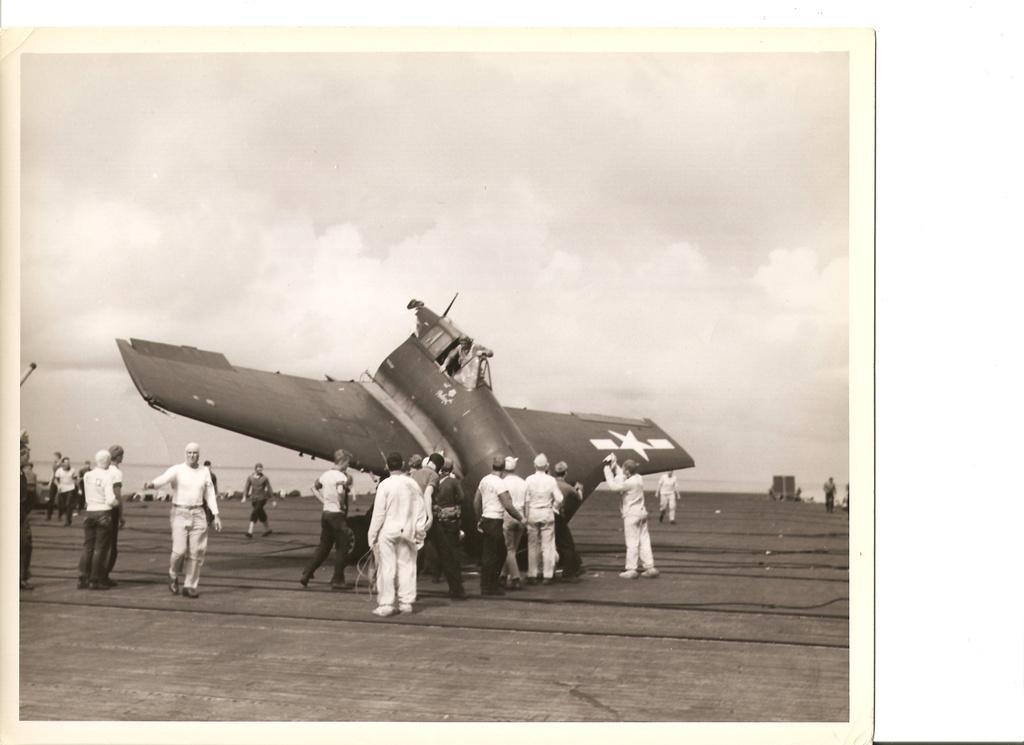Could you give a brief overview of what you see in this image? This is a black and white photo and here we can see people and there is an aircraft on the road. At the top, there is sky. 